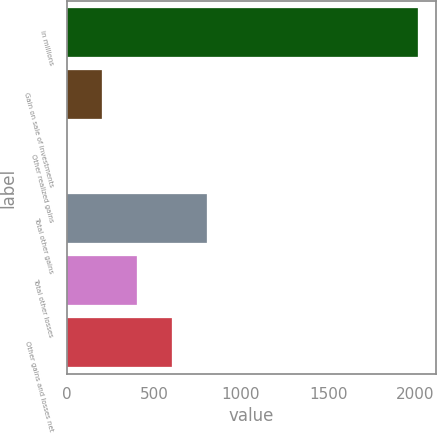Convert chart. <chart><loc_0><loc_0><loc_500><loc_500><bar_chart><fcel>in millions<fcel>Gain on sale of investments<fcel>Other realized gains<fcel>Total other gains<fcel>Total other losses<fcel>Other gains and losses net<nl><fcel>2016<fcel>202.86<fcel>1.4<fcel>807.24<fcel>404.32<fcel>605.78<nl></chart> 